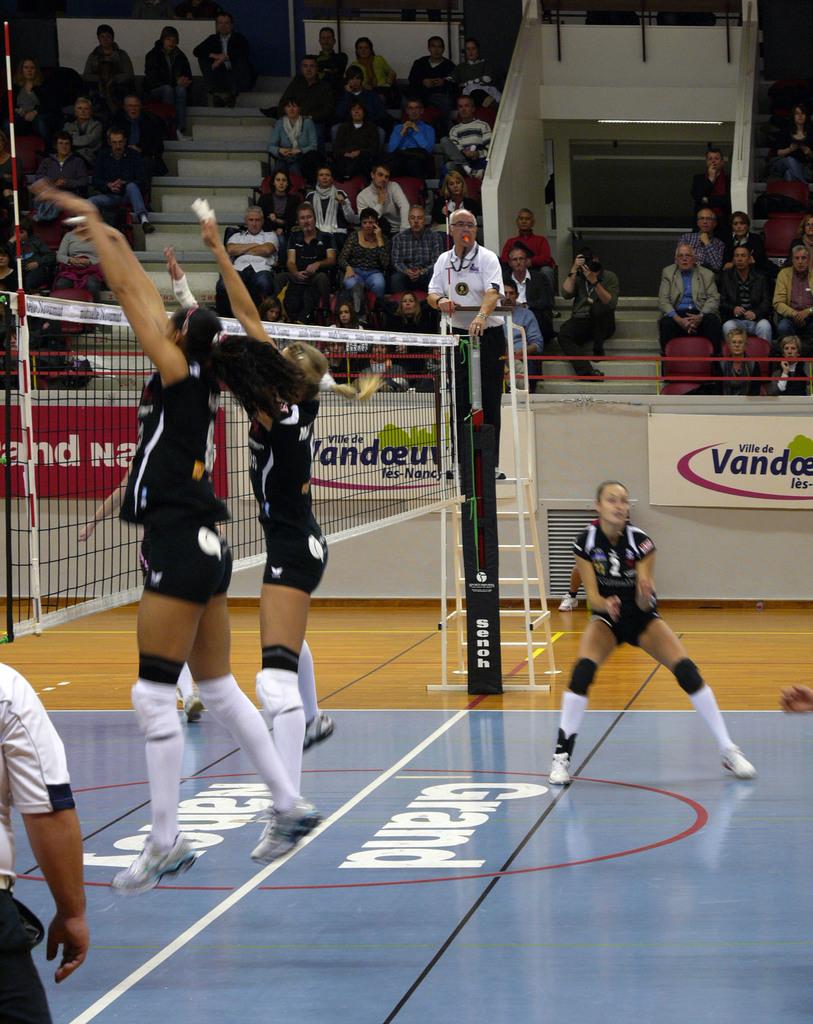What is the word written on the floor closest to the player standing on the ground?
Ensure brevity in your answer.  Grand. What is the ad in the background for?
Provide a short and direct response. Vandage. 